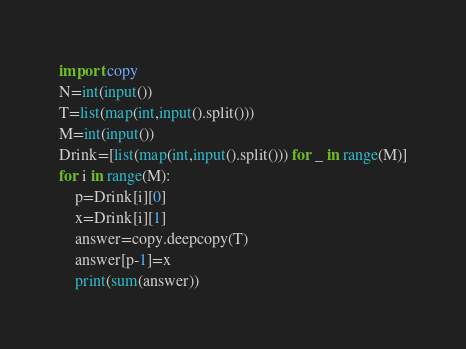Convert code to text. <code><loc_0><loc_0><loc_500><loc_500><_Python_>import copy
N=int(input())
T=list(map(int,input().split()))
M=int(input())
Drink=[list(map(int,input().split())) for _ in range(M)]
for i in range(M):
    p=Drink[i][0]
    x=Drink[i][1]
    answer=copy.deepcopy(T)
    answer[p-1]=x
    print(sum(answer))
</code> 